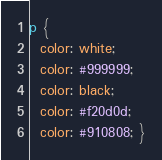Convert code to text. <code><loc_0><loc_0><loc_500><loc_500><_CSS_>p {
  color: white;
  color: #999999;
  color: black;
  color: #f20d0d;
  color: #910808; }
</code> 